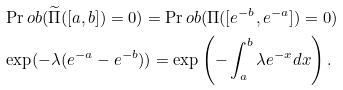Convert formula to latex. <formula><loc_0><loc_0><loc_500><loc_500>& \Pr o b ( \widetilde { \Pi } ( [ a , b ] ) = 0 ) = \Pr o b ( \Pi ( [ e ^ { - b } , e ^ { - a } ] ) = 0 ) \\ & \exp ( - \lambda ( e ^ { - a } - e ^ { - b } ) ) = \exp \left ( - \int _ { a } ^ { b } \lambda e ^ { - x } d x \right ) .</formula> 